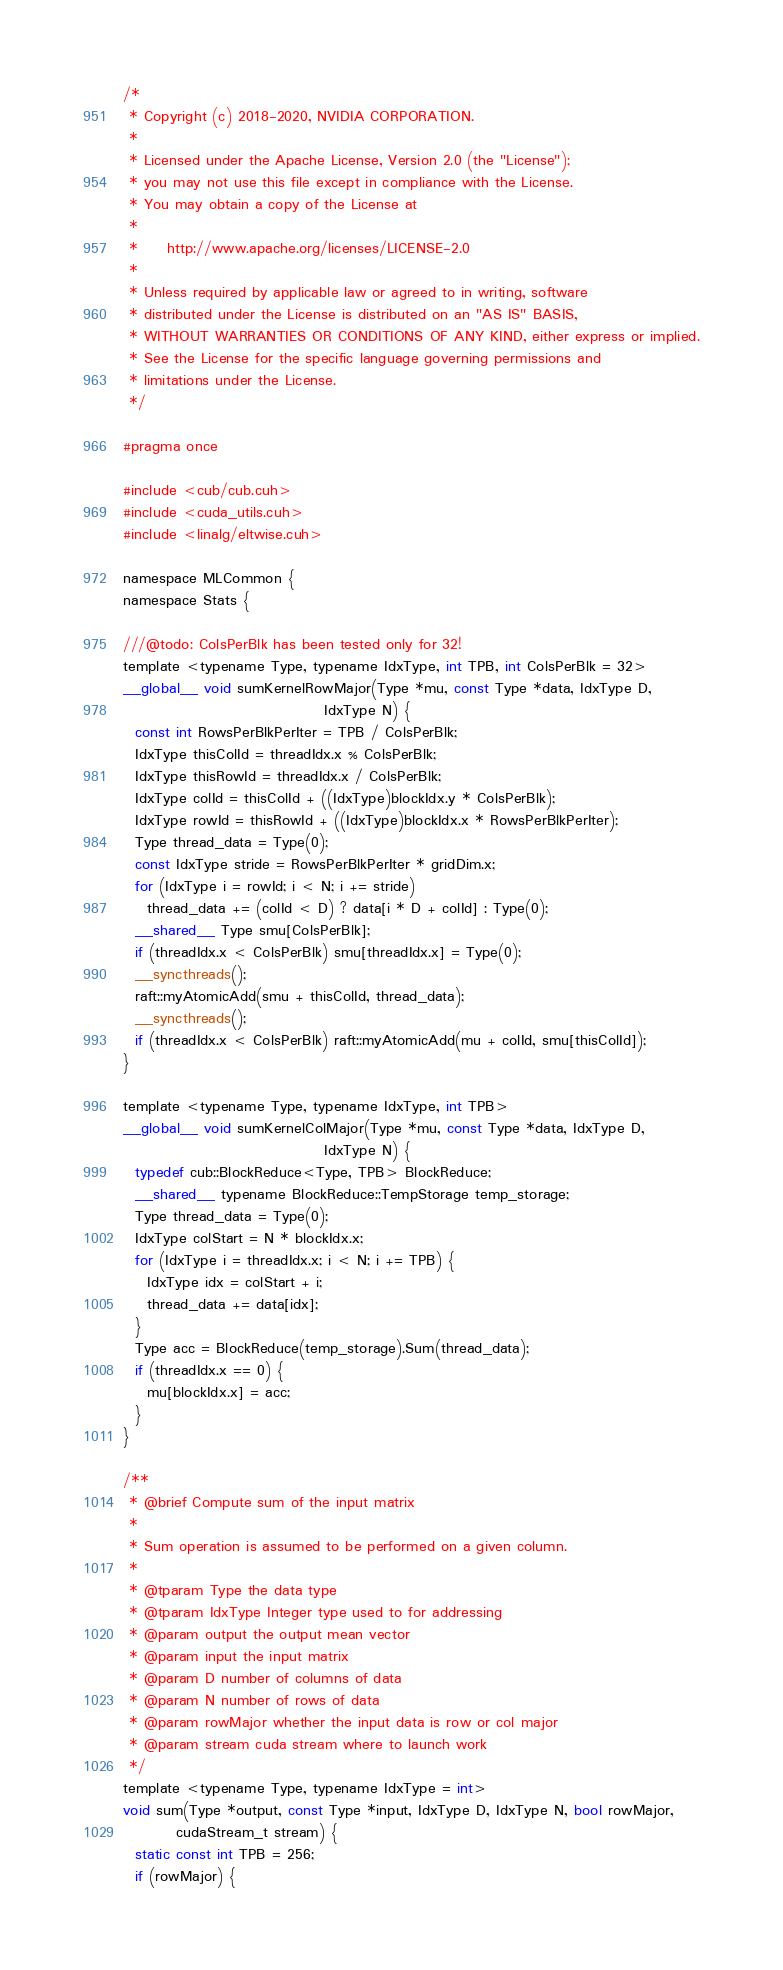<code> <loc_0><loc_0><loc_500><loc_500><_Cuda_>/*
 * Copyright (c) 2018-2020, NVIDIA CORPORATION.
 *
 * Licensed under the Apache License, Version 2.0 (the "License");
 * you may not use this file except in compliance with the License.
 * You may obtain a copy of the License at
 *
 *     http://www.apache.org/licenses/LICENSE-2.0
 *
 * Unless required by applicable law or agreed to in writing, software
 * distributed under the License is distributed on an "AS IS" BASIS,
 * WITHOUT WARRANTIES OR CONDITIONS OF ANY KIND, either express or implied.
 * See the License for the specific language governing permissions and
 * limitations under the License.
 */

#pragma once

#include <cub/cub.cuh>
#include <cuda_utils.cuh>
#include <linalg/eltwise.cuh>

namespace MLCommon {
namespace Stats {

///@todo: ColsPerBlk has been tested only for 32!
template <typename Type, typename IdxType, int TPB, int ColsPerBlk = 32>
__global__ void sumKernelRowMajor(Type *mu, const Type *data, IdxType D,
                                  IdxType N) {
  const int RowsPerBlkPerIter = TPB / ColsPerBlk;
  IdxType thisColId = threadIdx.x % ColsPerBlk;
  IdxType thisRowId = threadIdx.x / ColsPerBlk;
  IdxType colId = thisColId + ((IdxType)blockIdx.y * ColsPerBlk);
  IdxType rowId = thisRowId + ((IdxType)blockIdx.x * RowsPerBlkPerIter);
  Type thread_data = Type(0);
  const IdxType stride = RowsPerBlkPerIter * gridDim.x;
  for (IdxType i = rowId; i < N; i += stride)
    thread_data += (colId < D) ? data[i * D + colId] : Type(0);
  __shared__ Type smu[ColsPerBlk];
  if (threadIdx.x < ColsPerBlk) smu[threadIdx.x] = Type(0);
  __syncthreads();
  raft::myAtomicAdd(smu + thisColId, thread_data);
  __syncthreads();
  if (threadIdx.x < ColsPerBlk) raft::myAtomicAdd(mu + colId, smu[thisColId]);
}

template <typename Type, typename IdxType, int TPB>
__global__ void sumKernelColMajor(Type *mu, const Type *data, IdxType D,
                                  IdxType N) {
  typedef cub::BlockReduce<Type, TPB> BlockReduce;
  __shared__ typename BlockReduce::TempStorage temp_storage;
  Type thread_data = Type(0);
  IdxType colStart = N * blockIdx.x;
  for (IdxType i = threadIdx.x; i < N; i += TPB) {
    IdxType idx = colStart + i;
    thread_data += data[idx];
  }
  Type acc = BlockReduce(temp_storage).Sum(thread_data);
  if (threadIdx.x == 0) {
    mu[blockIdx.x] = acc;
  }
}

/**
 * @brief Compute sum of the input matrix
 *
 * Sum operation is assumed to be performed on a given column.
 *
 * @tparam Type the data type
 * @tparam IdxType Integer type used to for addressing
 * @param output the output mean vector
 * @param input the input matrix
 * @param D number of columns of data
 * @param N number of rows of data
 * @param rowMajor whether the input data is row or col major
 * @param stream cuda stream where to launch work
 */
template <typename Type, typename IdxType = int>
void sum(Type *output, const Type *input, IdxType D, IdxType N, bool rowMajor,
         cudaStream_t stream) {
  static const int TPB = 256;
  if (rowMajor) {</code> 